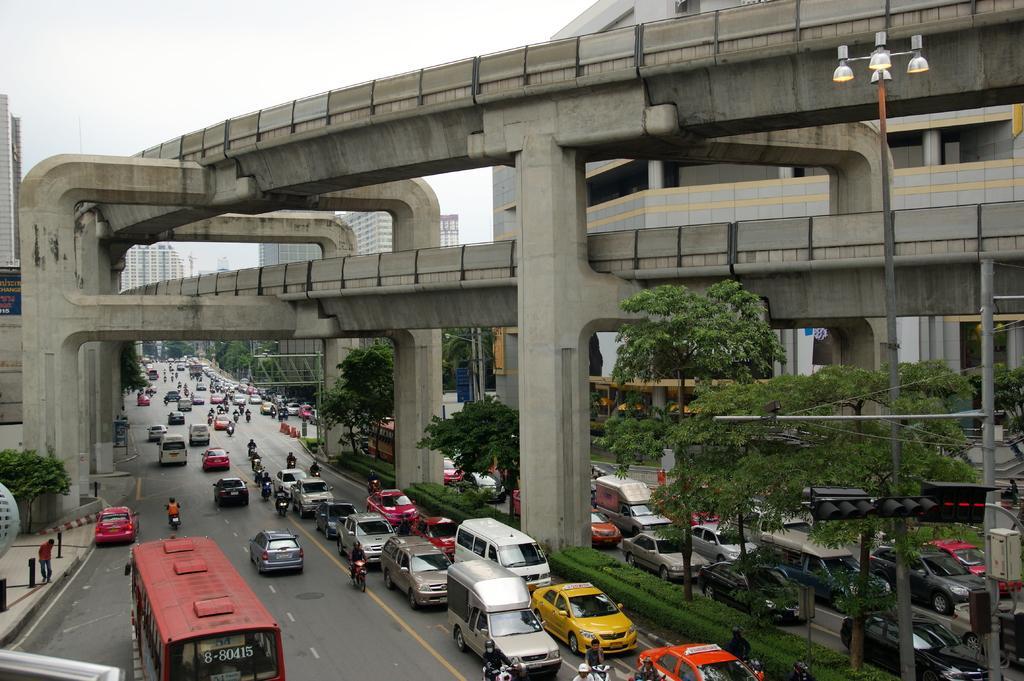How would you summarize this image in a sentence or two? In this image we can see few vehicles on the road, a person and few rods on the pavement, there is a pole with lights, traffic lights and a box , there are bridges, few buildings and the sky in the background. 